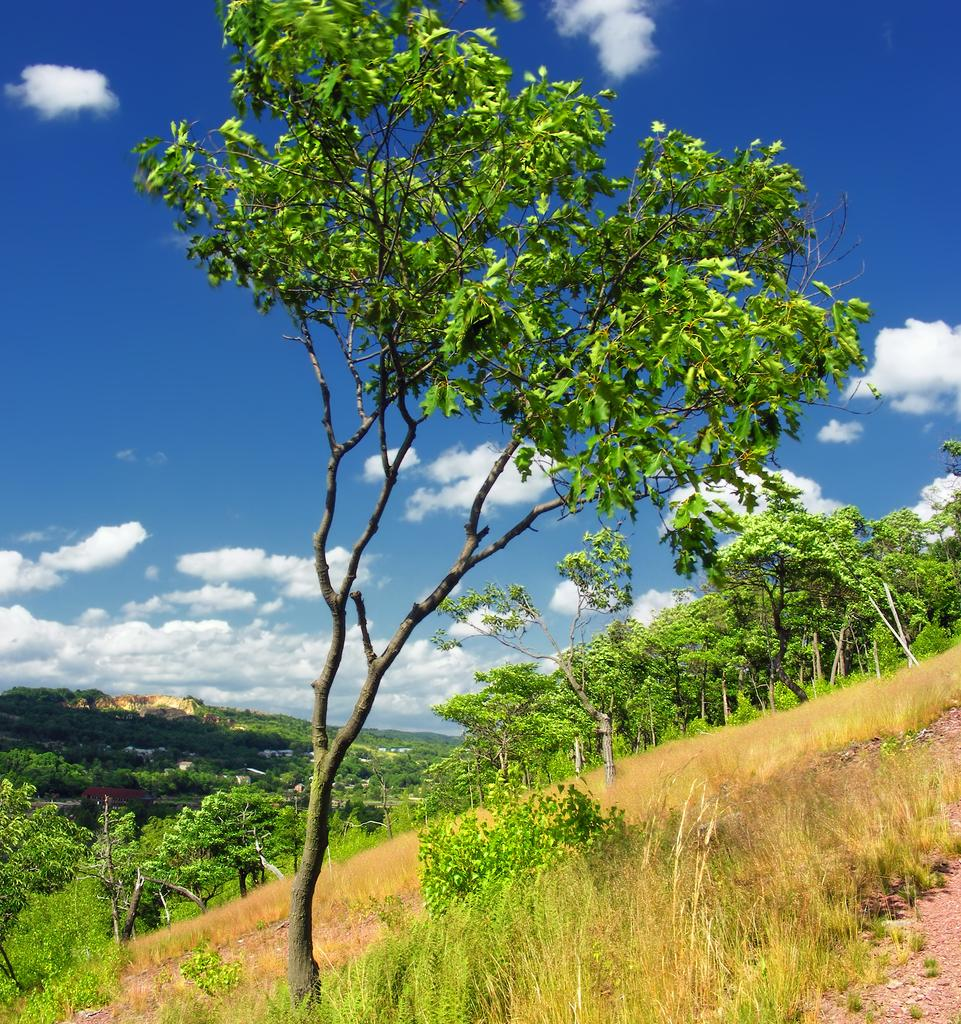What type of vegetation can be seen in the foreground of the image? Greenery and grass are visible in the foreground of the image. What is visible in the background of the image? There is greenery and the sky visible in the background of the image. Can you describe the sky in the image? The sky is visible in the background of the image, and clouds are present. What type of bell can be heard ringing in the image? There is no bell present in the image, and therefore no sound can be heard. 